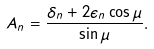Convert formula to latex. <formula><loc_0><loc_0><loc_500><loc_500>A _ { n } = \frac { \delta _ { n } + 2 \epsilon _ { n } \cos \mu } { \sin \mu } .</formula> 